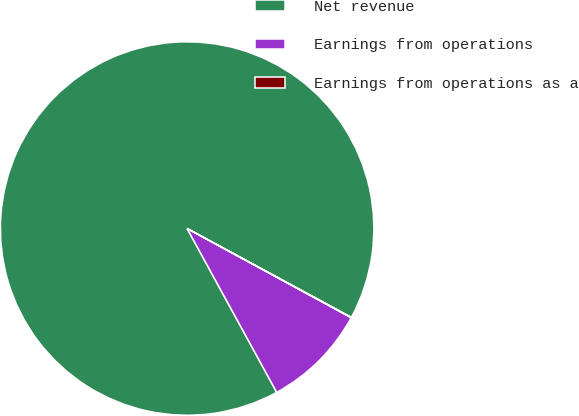Convert chart. <chart><loc_0><loc_0><loc_500><loc_500><pie_chart><fcel>Net revenue<fcel>Earnings from operations<fcel>Earnings from operations as a<nl><fcel>90.86%<fcel>9.11%<fcel>0.03%<nl></chart> 